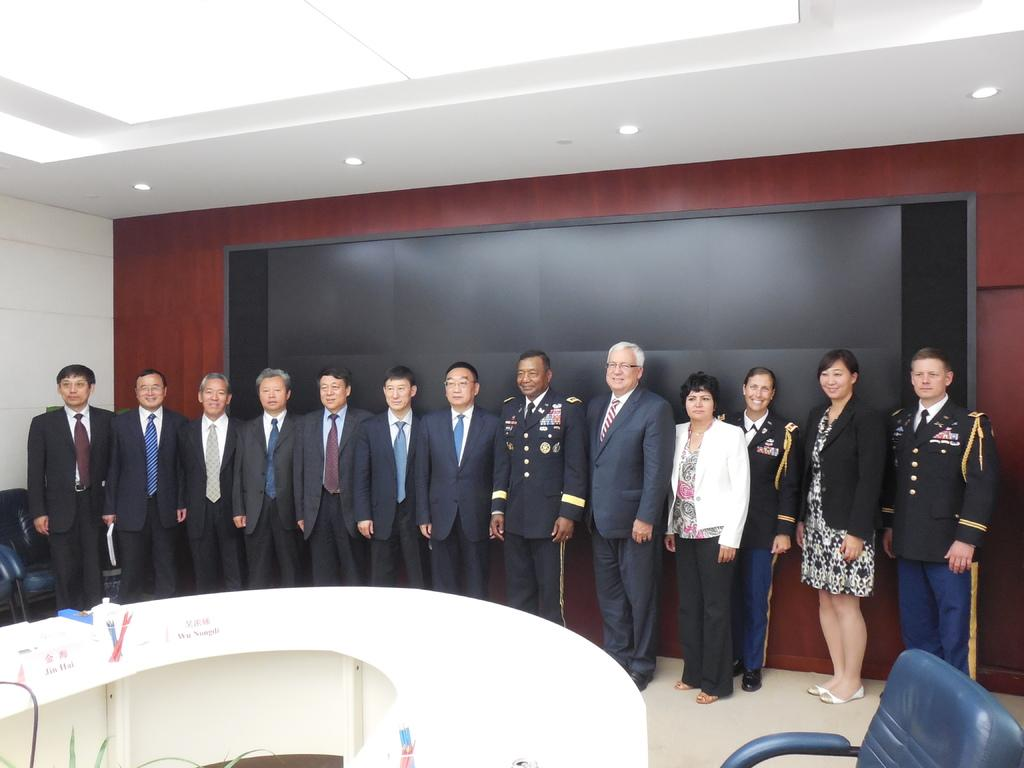What is happening in the image involving people? There is a group of people standing in the image. What can be seen on the table in the image? There are objects on a table in the image. What furniture is present in the image? There are chairs in the image. What type of illumination is visible in the image? There are lights in the image. What is on the wall in the background of the image? There is a screen on the wall in the background of the image. Can you tell me how many airplanes are flying in the image? There are no airplanes visible in the image; it features a group of people, objects on a table, chairs, lights, and a screen on the wall. What type of mine is depicted in the image? There is no mine present in the image. 